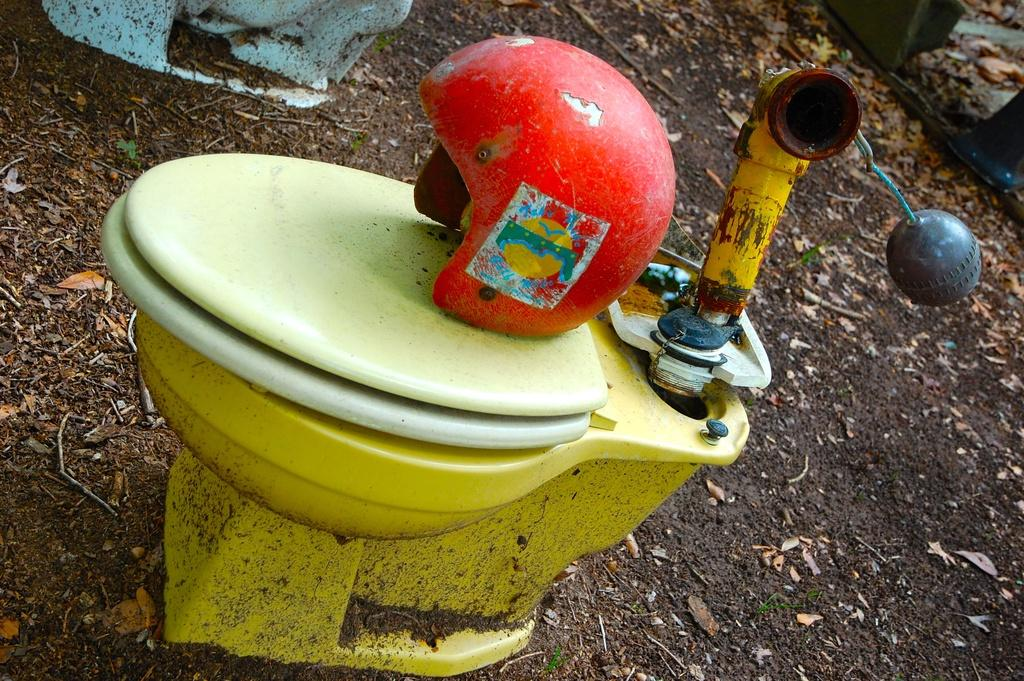What object is present in the image that is typically used for head protection? There is a helmet in the image. Where is the helmet placed in the image? The helmet is placed on a toilet seat. What is connected to the helmet in the image? There is a pipe attached to the helmet. What else is attached to the helmet in the image? There is a ball attached to the helmet. What type of fork can be seen being used by the laborer in the image? There is no fork or laborer present in the image. How many clams are visible in the image? There are no clams present in the image. 